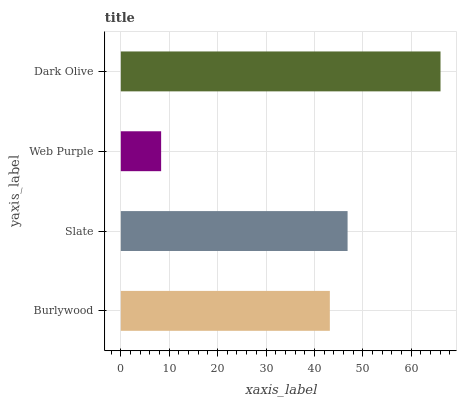Is Web Purple the minimum?
Answer yes or no. Yes. Is Dark Olive the maximum?
Answer yes or no. Yes. Is Slate the minimum?
Answer yes or no. No. Is Slate the maximum?
Answer yes or no. No. Is Slate greater than Burlywood?
Answer yes or no. Yes. Is Burlywood less than Slate?
Answer yes or no. Yes. Is Burlywood greater than Slate?
Answer yes or no. No. Is Slate less than Burlywood?
Answer yes or no. No. Is Slate the high median?
Answer yes or no. Yes. Is Burlywood the low median?
Answer yes or no. Yes. Is Dark Olive the high median?
Answer yes or no. No. Is Slate the low median?
Answer yes or no. No. 